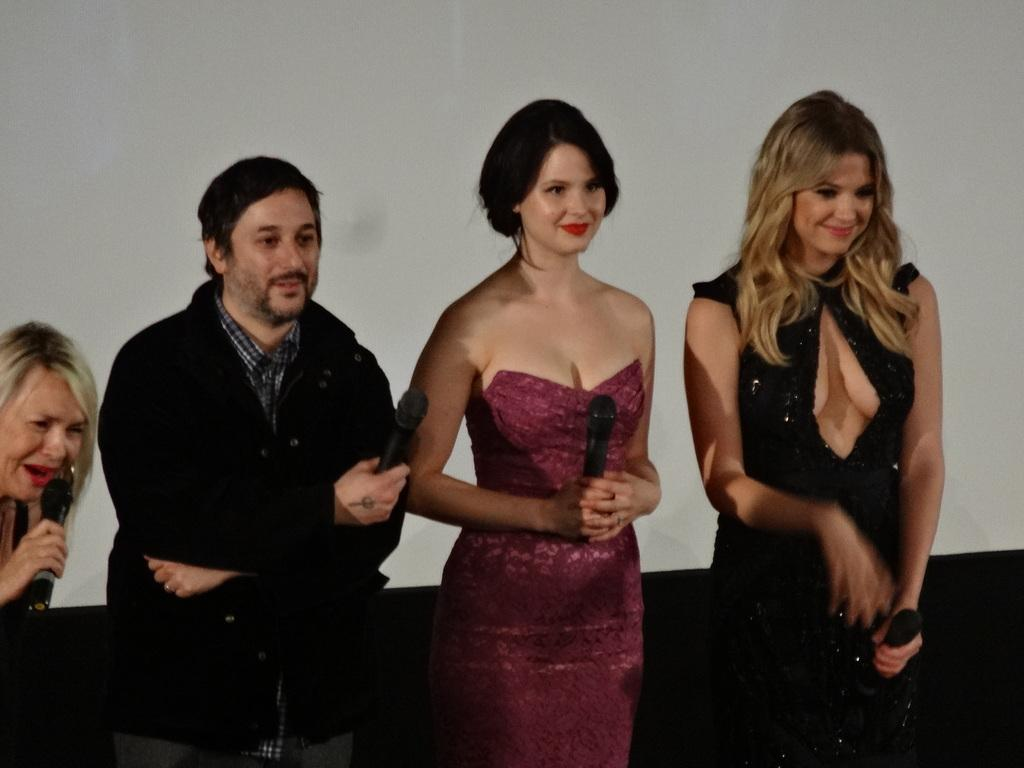How many people are in the image? There are three people in the image. Where are the people located in the image? The three people are standing on the left side of the image. Can you describe the gender of one of the people? There is a woman among the three people. What is the woman holding in the image? The woman is holding a microphone. What is the general expression of the people in the image? The people in the image are smiling. What type of shade is covering the vase in the image? There is no shade or vase present in the image. 